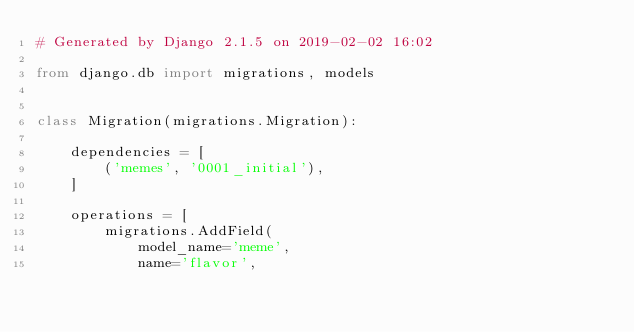Convert code to text. <code><loc_0><loc_0><loc_500><loc_500><_Python_># Generated by Django 2.1.5 on 2019-02-02 16:02

from django.db import migrations, models


class Migration(migrations.Migration):

    dependencies = [
        ('memes', '0001_initial'),
    ]

    operations = [
        migrations.AddField(
            model_name='meme',
            name='flavor',</code> 